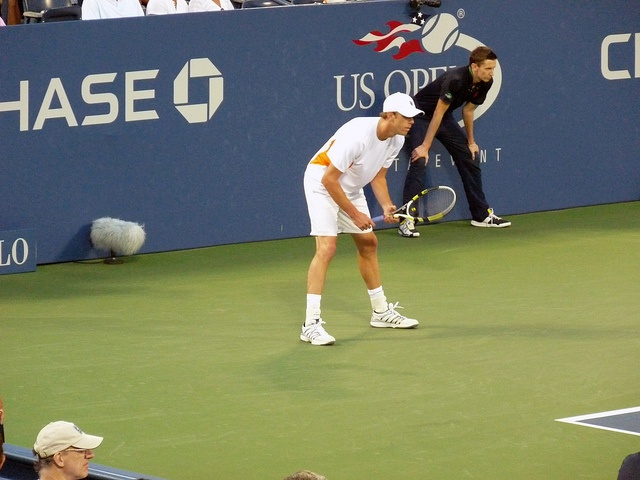Describe the objects in this image and their specific colors. I can see people in olive, white, tan, and brown tones, people in olive, black, gray, and maroon tones, people in olive, beige, and tan tones, tennis racket in olive, gray, black, darkgray, and ivory tones, and people in olive, white, gray, and darkgray tones in this image. 